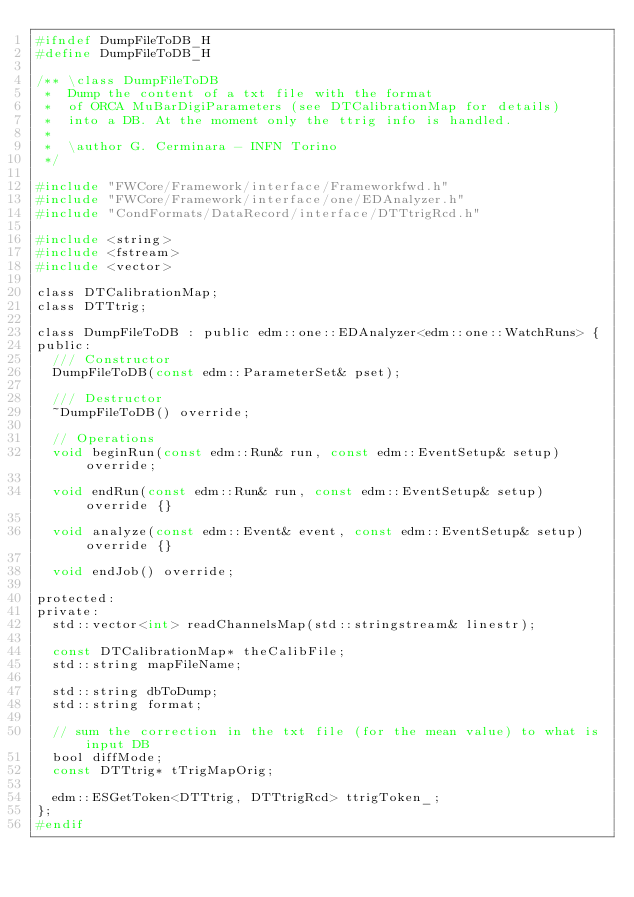<code> <loc_0><loc_0><loc_500><loc_500><_C_>#ifndef DumpFileToDB_H
#define DumpFileToDB_H

/** \class DumpFileToDB
 *  Dump the content of a txt file with the format
 *  of ORCA MuBarDigiParameters (see DTCalibrationMap for details)
 *  into a DB. At the moment only the ttrig info is handled.
 *
 *  \author G. Cerminara - INFN Torino
 */

#include "FWCore/Framework/interface/Frameworkfwd.h"
#include "FWCore/Framework/interface/one/EDAnalyzer.h"
#include "CondFormats/DataRecord/interface/DTTtrigRcd.h"

#include <string>
#include <fstream>
#include <vector>

class DTCalibrationMap;
class DTTtrig;

class DumpFileToDB : public edm::one::EDAnalyzer<edm::one::WatchRuns> {
public:
  /// Constructor
  DumpFileToDB(const edm::ParameterSet& pset);

  /// Destructor
  ~DumpFileToDB() override;

  // Operations
  void beginRun(const edm::Run& run, const edm::EventSetup& setup) override;

  void endRun(const edm::Run& run, const edm::EventSetup& setup) override {}

  void analyze(const edm::Event& event, const edm::EventSetup& setup) override {}

  void endJob() override;

protected:
private:
  std::vector<int> readChannelsMap(std::stringstream& linestr);

  const DTCalibrationMap* theCalibFile;
  std::string mapFileName;

  std::string dbToDump;
  std::string format;

  // sum the correction in the txt file (for the mean value) to what is input DB
  bool diffMode;
  const DTTtrig* tTrigMapOrig;

  edm::ESGetToken<DTTtrig, DTTtrigRcd> ttrigToken_;
};
#endif
</code> 